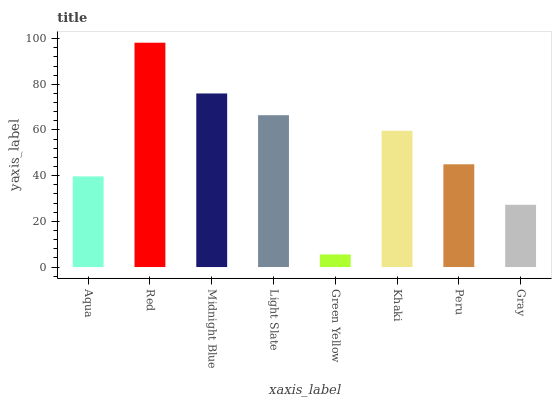Is Green Yellow the minimum?
Answer yes or no. Yes. Is Red the maximum?
Answer yes or no. Yes. Is Midnight Blue the minimum?
Answer yes or no. No. Is Midnight Blue the maximum?
Answer yes or no. No. Is Red greater than Midnight Blue?
Answer yes or no. Yes. Is Midnight Blue less than Red?
Answer yes or no. Yes. Is Midnight Blue greater than Red?
Answer yes or no. No. Is Red less than Midnight Blue?
Answer yes or no. No. Is Khaki the high median?
Answer yes or no. Yes. Is Peru the low median?
Answer yes or no. Yes. Is Light Slate the high median?
Answer yes or no. No. Is Khaki the low median?
Answer yes or no. No. 